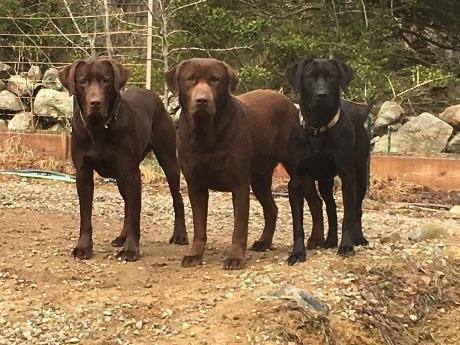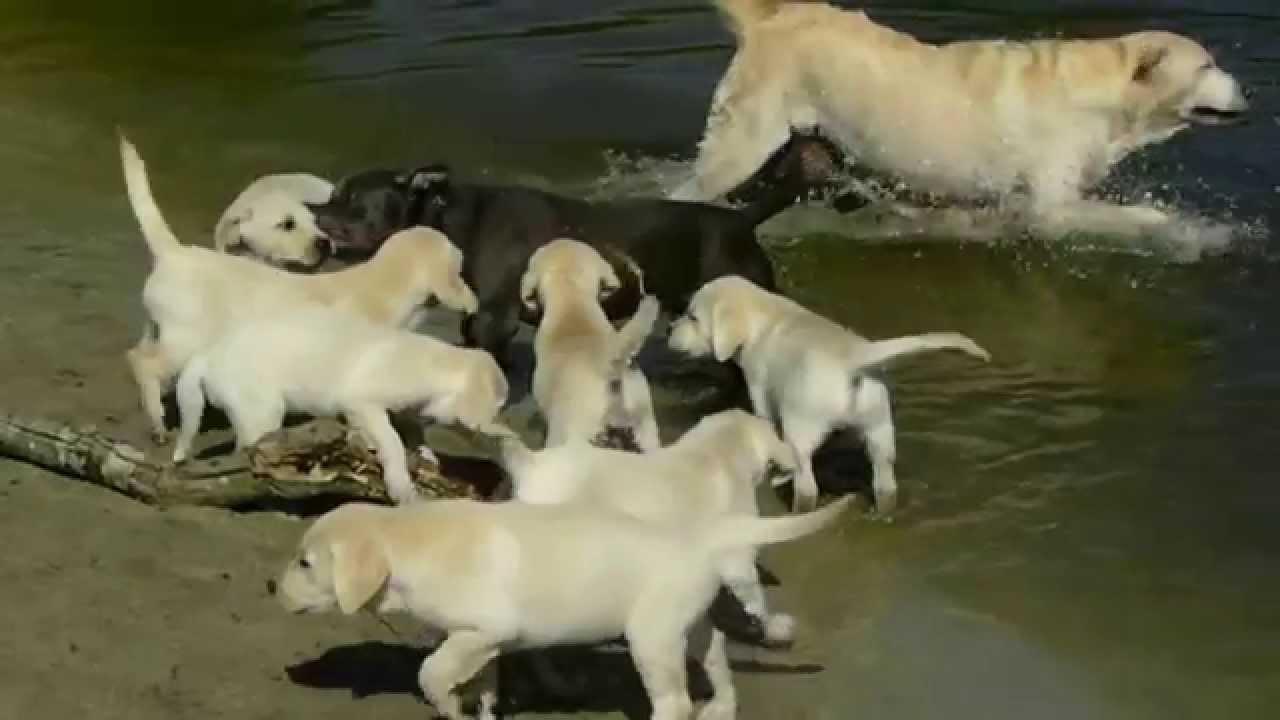The first image is the image on the left, the second image is the image on the right. Examine the images to the left and right. Is the description "Some of the dogs are in the water, and only one dog near the water is not """"blond""""." accurate? Answer yes or no. Yes. The first image is the image on the left, the second image is the image on the right. For the images displayed, is the sentence "The dogs in the image on the right are near the water." factually correct? Answer yes or no. Yes. 